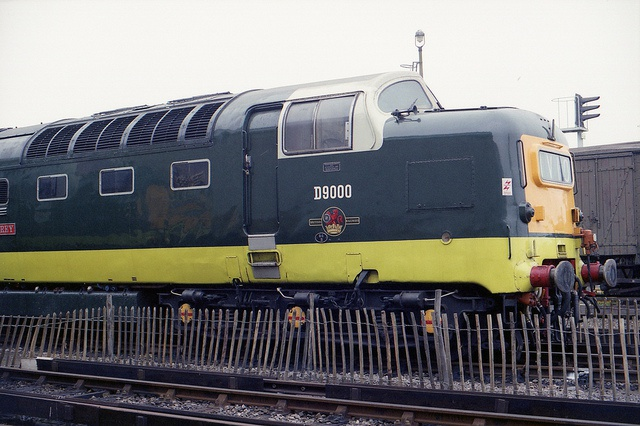Describe the objects in this image and their specific colors. I can see train in lightgray, black, darkblue, and olive tones and traffic light in lightgray, gray, darkgray, and navy tones in this image. 